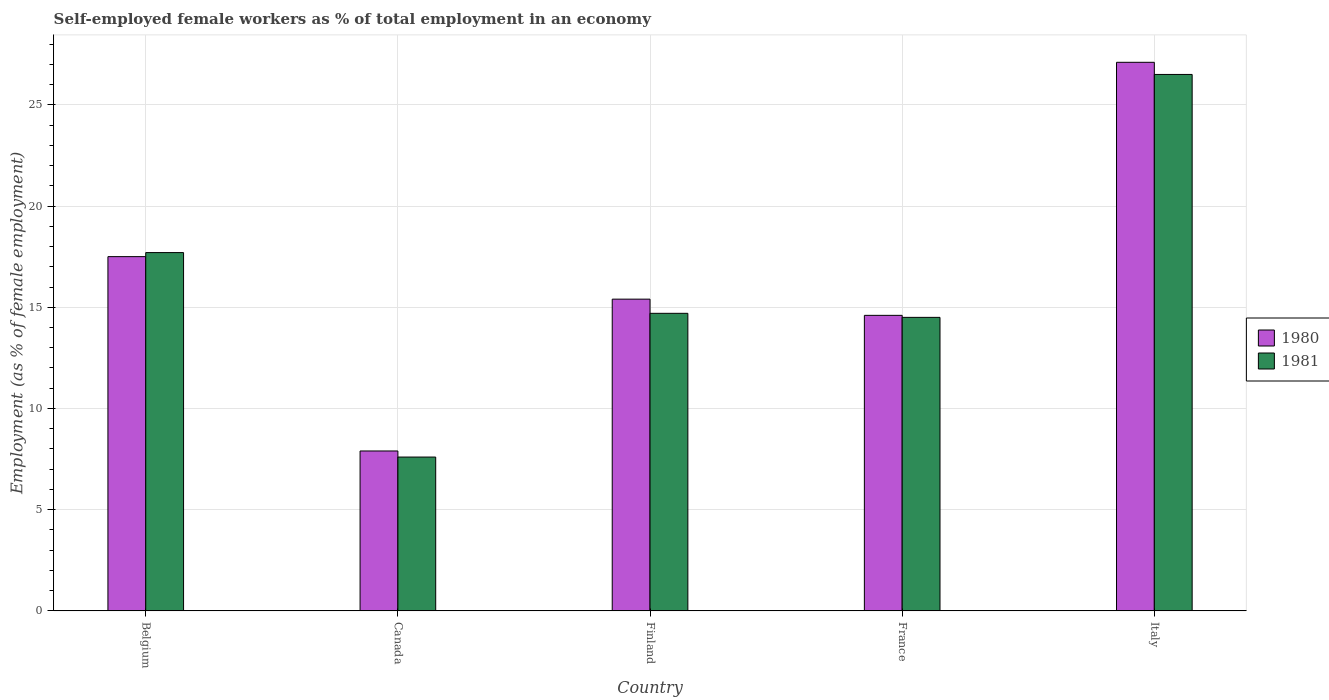How many groups of bars are there?
Your response must be concise. 5. Are the number of bars on each tick of the X-axis equal?
Ensure brevity in your answer.  Yes. How many bars are there on the 1st tick from the right?
Offer a terse response. 2. What is the label of the 1st group of bars from the left?
Your answer should be compact. Belgium. What is the percentage of self-employed female workers in 1981 in Belgium?
Provide a short and direct response. 17.7. Across all countries, what is the maximum percentage of self-employed female workers in 1980?
Provide a short and direct response. 27.1. Across all countries, what is the minimum percentage of self-employed female workers in 1980?
Provide a short and direct response. 7.9. In which country was the percentage of self-employed female workers in 1980 maximum?
Offer a terse response. Italy. What is the total percentage of self-employed female workers in 1980 in the graph?
Make the answer very short. 82.5. What is the difference between the percentage of self-employed female workers in 1981 in France and that in Italy?
Provide a short and direct response. -12. What is the average percentage of self-employed female workers in 1980 per country?
Ensure brevity in your answer.  16.5. What is the difference between the percentage of self-employed female workers of/in 1981 and percentage of self-employed female workers of/in 1980 in Canada?
Give a very brief answer. -0.3. What is the ratio of the percentage of self-employed female workers in 1981 in Belgium to that in Finland?
Provide a short and direct response. 1.2. What is the difference between the highest and the second highest percentage of self-employed female workers in 1981?
Ensure brevity in your answer.  -8.8. What is the difference between the highest and the lowest percentage of self-employed female workers in 1980?
Your answer should be very brief. 19.2. Is the sum of the percentage of self-employed female workers in 1980 in Belgium and Canada greater than the maximum percentage of self-employed female workers in 1981 across all countries?
Your response must be concise. No. What does the 1st bar from the left in Belgium represents?
Provide a succinct answer. 1980. What does the 1st bar from the right in Canada represents?
Offer a very short reply. 1981. How many countries are there in the graph?
Keep it short and to the point. 5. Does the graph contain any zero values?
Ensure brevity in your answer.  No. Does the graph contain grids?
Your answer should be very brief. Yes. How are the legend labels stacked?
Your answer should be compact. Vertical. What is the title of the graph?
Your answer should be very brief. Self-employed female workers as % of total employment in an economy. Does "1975" appear as one of the legend labels in the graph?
Provide a short and direct response. No. What is the label or title of the X-axis?
Your answer should be very brief. Country. What is the label or title of the Y-axis?
Offer a terse response. Employment (as % of female employment). What is the Employment (as % of female employment) of 1981 in Belgium?
Provide a succinct answer. 17.7. What is the Employment (as % of female employment) of 1980 in Canada?
Your answer should be compact. 7.9. What is the Employment (as % of female employment) in 1981 in Canada?
Provide a succinct answer. 7.6. What is the Employment (as % of female employment) of 1980 in Finland?
Give a very brief answer. 15.4. What is the Employment (as % of female employment) in 1981 in Finland?
Make the answer very short. 14.7. What is the Employment (as % of female employment) in 1980 in France?
Your answer should be compact. 14.6. What is the Employment (as % of female employment) in 1980 in Italy?
Keep it short and to the point. 27.1. Across all countries, what is the maximum Employment (as % of female employment) of 1980?
Your response must be concise. 27.1. Across all countries, what is the maximum Employment (as % of female employment) in 1981?
Offer a terse response. 26.5. Across all countries, what is the minimum Employment (as % of female employment) of 1980?
Your response must be concise. 7.9. Across all countries, what is the minimum Employment (as % of female employment) in 1981?
Your answer should be compact. 7.6. What is the total Employment (as % of female employment) of 1980 in the graph?
Offer a very short reply. 82.5. What is the total Employment (as % of female employment) of 1981 in the graph?
Provide a succinct answer. 81. What is the difference between the Employment (as % of female employment) in 1980 in Belgium and that in Canada?
Provide a short and direct response. 9.6. What is the difference between the Employment (as % of female employment) in 1980 in Belgium and that in Finland?
Provide a short and direct response. 2.1. What is the difference between the Employment (as % of female employment) of 1980 in Belgium and that in France?
Provide a short and direct response. 2.9. What is the difference between the Employment (as % of female employment) of 1980 in Belgium and that in Italy?
Offer a terse response. -9.6. What is the difference between the Employment (as % of female employment) in 1981 in Belgium and that in Italy?
Provide a short and direct response. -8.8. What is the difference between the Employment (as % of female employment) in 1980 in Canada and that in Finland?
Give a very brief answer. -7.5. What is the difference between the Employment (as % of female employment) of 1980 in Canada and that in Italy?
Your response must be concise. -19.2. What is the difference between the Employment (as % of female employment) in 1981 in Canada and that in Italy?
Offer a very short reply. -18.9. What is the difference between the Employment (as % of female employment) in 1980 in Finland and that in France?
Your answer should be very brief. 0.8. What is the difference between the Employment (as % of female employment) of 1981 in Finland and that in France?
Provide a succinct answer. 0.2. What is the difference between the Employment (as % of female employment) of 1980 in Finland and that in Italy?
Offer a very short reply. -11.7. What is the difference between the Employment (as % of female employment) in 1981 in Finland and that in Italy?
Keep it short and to the point. -11.8. What is the difference between the Employment (as % of female employment) of 1980 in France and that in Italy?
Keep it short and to the point. -12.5. What is the difference between the Employment (as % of female employment) in 1981 in France and that in Italy?
Offer a terse response. -12. What is the difference between the Employment (as % of female employment) of 1980 in Belgium and the Employment (as % of female employment) of 1981 in Finland?
Offer a very short reply. 2.8. What is the difference between the Employment (as % of female employment) of 1980 in Belgium and the Employment (as % of female employment) of 1981 in France?
Your answer should be very brief. 3. What is the difference between the Employment (as % of female employment) of 1980 in Belgium and the Employment (as % of female employment) of 1981 in Italy?
Offer a very short reply. -9. What is the difference between the Employment (as % of female employment) of 1980 in Canada and the Employment (as % of female employment) of 1981 in France?
Keep it short and to the point. -6.6. What is the difference between the Employment (as % of female employment) in 1980 in Canada and the Employment (as % of female employment) in 1981 in Italy?
Make the answer very short. -18.6. What is the difference between the Employment (as % of female employment) in 1980 in Finland and the Employment (as % of female employment) in 1981 in Italy?
Offer a very short reply. -11.1. What is the average Employment (as % of female employment) in 1980 per country?
Make the answer very short. 16.5. What is the average Employment (as % of female employment) in 1981 per country?
Your answer should be very brief. 16.2. What is the ratio of the Employment (as % of female employment) of 1980 in Belgium to that in Canada?
Provide a succinct answer. 2.22. What is the ratio of the Employment (as % of female employment) of 1981 in Belgium to that in Canada?
Your response must be concise. 2.33. What is the ratio of the Employment (as % of female employment) in 1980 in Belgium to that in Finland?
Ensure brevity in your answer.  1.14. What is the ratio of the Employment (as % of female employment) of 1981 in Belgium to that in Finland?
Provide a short and direct response. 1.2. What is the ratio of the Employment (as % of female employment) of 1980 in Belgium to that in France?
Keep it short and to the point. 1.2. What is the ratio of the Employment (as % of female employment) in 1981 in Belgium to that in France?
Provide a succinct answer. 1.22. What is the ratio of the Employment (as % of female employment) of 1980 in Belgium to that in Italy?
Ensure brevity in your answer.  0.65. What is the ratio of the Employment (as % of female employment) in 1981 in Belgium to that in Italy?
Make the answer very short. 0.67. What is the ratio of the Employment (as % of female employment) of 1980 in Canada to that in Finland?
Provide a succinct answer. 0.51. What is the ratio of the Employment (as % of female employment) in 1981 in Canada to that in Finland?
Offer a very short reply. 0.52. What is the ratio of the Employment (as % of female employment) of 1980 in Canada to that in France?
Provide a short and direct response. 0.54. What is the ratio of the Employment (as % of female employment) in 1981 in Canada to that in France?
Offer a terse response. 0.52. What is the ratio of the Employment (as % of female employment) of 1980 in Canada to that in Italy?
Make the answer very short. 0.29. What is the ratio of the Employment (as % of female employment) of 1981 in Canada to that in Italy?
Make the answer very short. 0.29. What is the ratio of the Employment (as % of female employment) of 1980 in Finland to that in France?
Offer a terse response. 1.05. What is the ratio of the Employment (as % of female employment) in 1981 in Finland to that in France?
Your answer should be very brief. 1.01. What is the ratio of the Employment (as % of female employment) in 1980 in Finland to that in Italy?
Your response must be concise. 0.57. What is the ratio of the Employment (as % of female employment) of 1981 in Finland to that in Italy?
Keep it short and to the point. 0.55. What is the ratio of the Employment (as % of female employment) of 1980 in France to that in Italy?
Make the answer very short. 0.54. What is the ratio of the Employment (as % of female employment) in 1981 in France to that in Italy?
Your response must be concise. 0.55. What is the difference between the highest and the second highest Employment (as % of female employment) in 1980?
Provide a succinct answer. 9.6. What is the difference between the highest and the second highest Employment (as % of female employment) of 1981?
Provide a short and direct response. 8.8. 